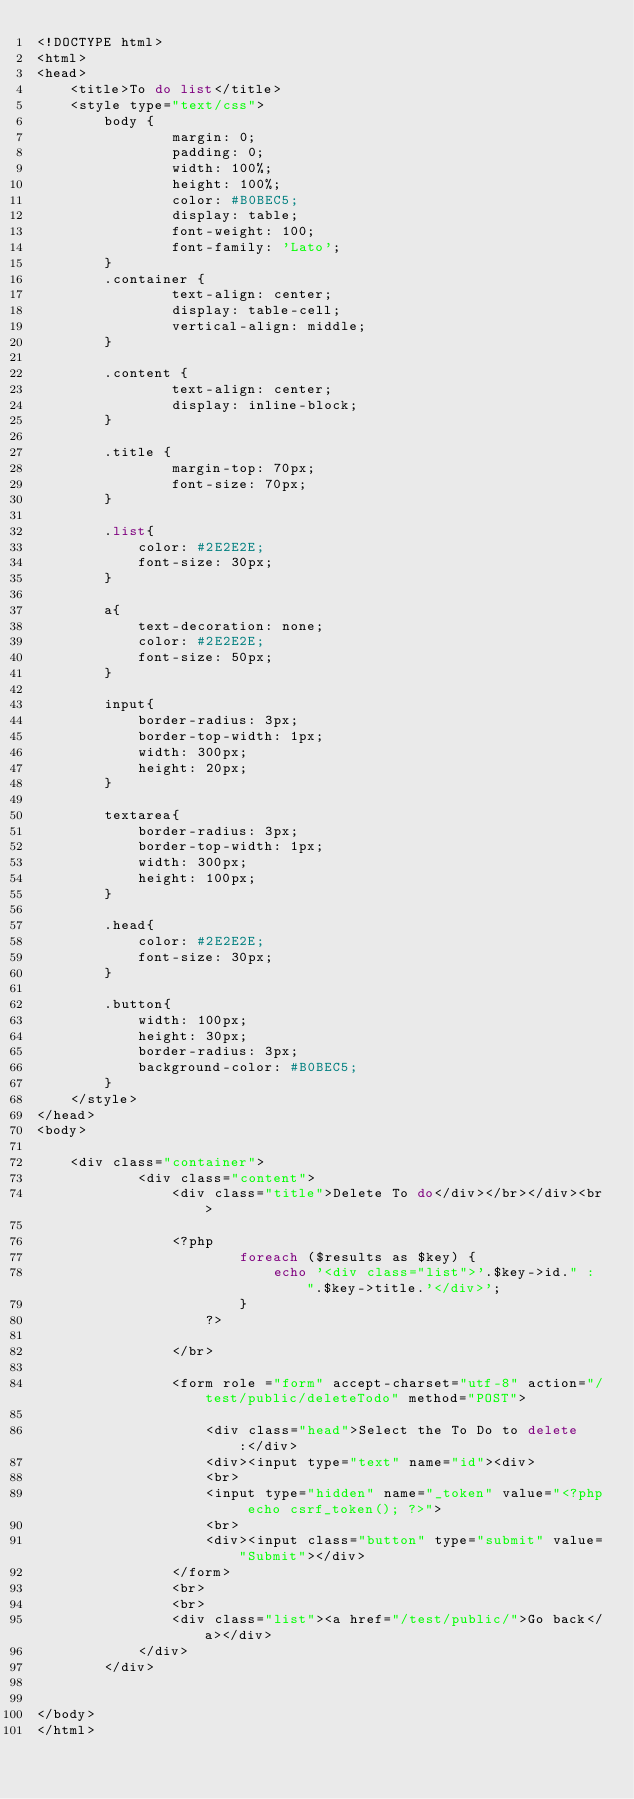<code> <loc_0><loc_0><loc_500><loc_500><_PHP_><!DOCTYPE html>
<html>
<head>
	<title>To do list</title>
	<style type="text/css">
		body {
				margin: 0;
				padding: 0;
				width: 100%;
				height: 100%;
				color: #B0BEC5;
				display: table;
				font-weight: 100;
				font-family: 'Lato';
		}
		.container {
				text-align: center;
				display: table-cell;
				vertical-align: middle;
		}

		.content {
				text-align: center;
				display: inline-block;
		}

		.title {
				margin-top: 70px;
				font-size: 70px;
		}

		.list{
			color: #2E2E2E;
			font-size: 30px;
		}

		a{
			text-decoration: none;
			color: #2E2E2E;
			font-size: 50px;
		}

		input{
			border-radius: 3px;
			border-top-width: 1px;
			width: 300px;
			height: 20px;
		}

		textarea{
			border-radius: 3px;
			border-top-width: 1px;
			width: 300px;
			height: 100px;
		}

		.head{
			color: #2E2E2E;
			font-size: 30px;
		}

		.button{
			width: 100px;
			height: 30px;
			border-radius: 3px;
			background-color: #B0BEC5;
		}
	</style>
</head>
<body>

	<div class="container">
			<div class="content">
				<div class="title">Delete To do</div></br></div><br>

				<?php
						foreach ($results as $key) {
							echo '<div class="list">'.$key->id." : ".$key->title.'</div>';
						}
					?>

				</br>
				
				<form role ="form" accept-charset="utf-8" action="/test/public/deleteTodo" method="POST">

					<div class="head">Select the To Do to delete :</div>
					<div><input type="text" name="id"><div>
					<br>
					<input type="hidden" name="_token" value="<?php echo csrf_token(); ?>">
					<br>
					<div><input class="button" type="submit" value="Submit"></div>
				</form>
				<br>
				<br>
				<div class="list"><a href="/test/public/">Go back</a></div>
			</div>
		</div>


</body>
</html>
</code> 